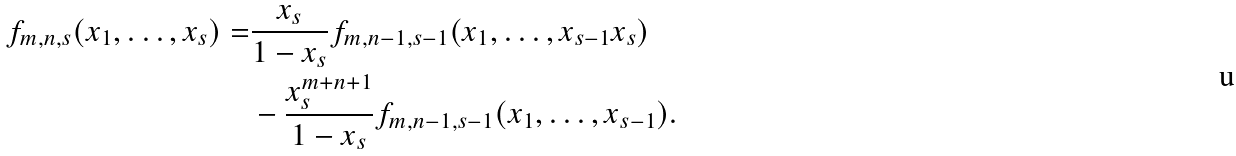<formula> <loc_0><loc_0><loc_500><loc_500>f _ { m , n , s } ( x _ { 1 } , \dots , x _ { s } ) = & \frac { x _ { s } } { 1 - x _ { s } } f _ { m , n - 1 , s - 1 } ( x _ { 1 } , \dots , x _ { s - 1 } x _ { s } ) \\ & - \frac { x _ { s } ^ { m + n + 1 } } { 1 - x _ { s } } f _ { m , n - 1 , s - 1 } ( x _ { 1 } , \dots , x _ { s - 1 } ) .</formula> 